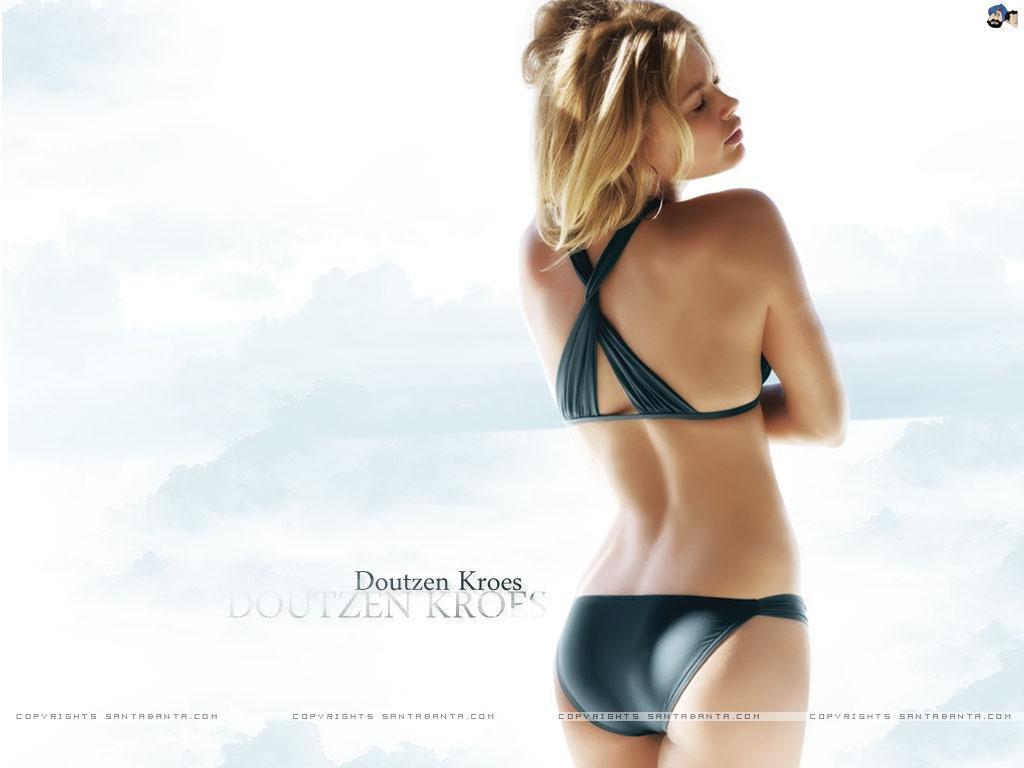In one or two sentences, can you explain what this image depicts? In this image, we can see a lady standing and there is some text written on the left. 